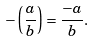Convert formula to latex. <formula><loc_0><loc_0><loc_500><loc_500>- \left ( { \frac { a } { b } } \right ) = { \frac { - a } { b } } .</formula> 